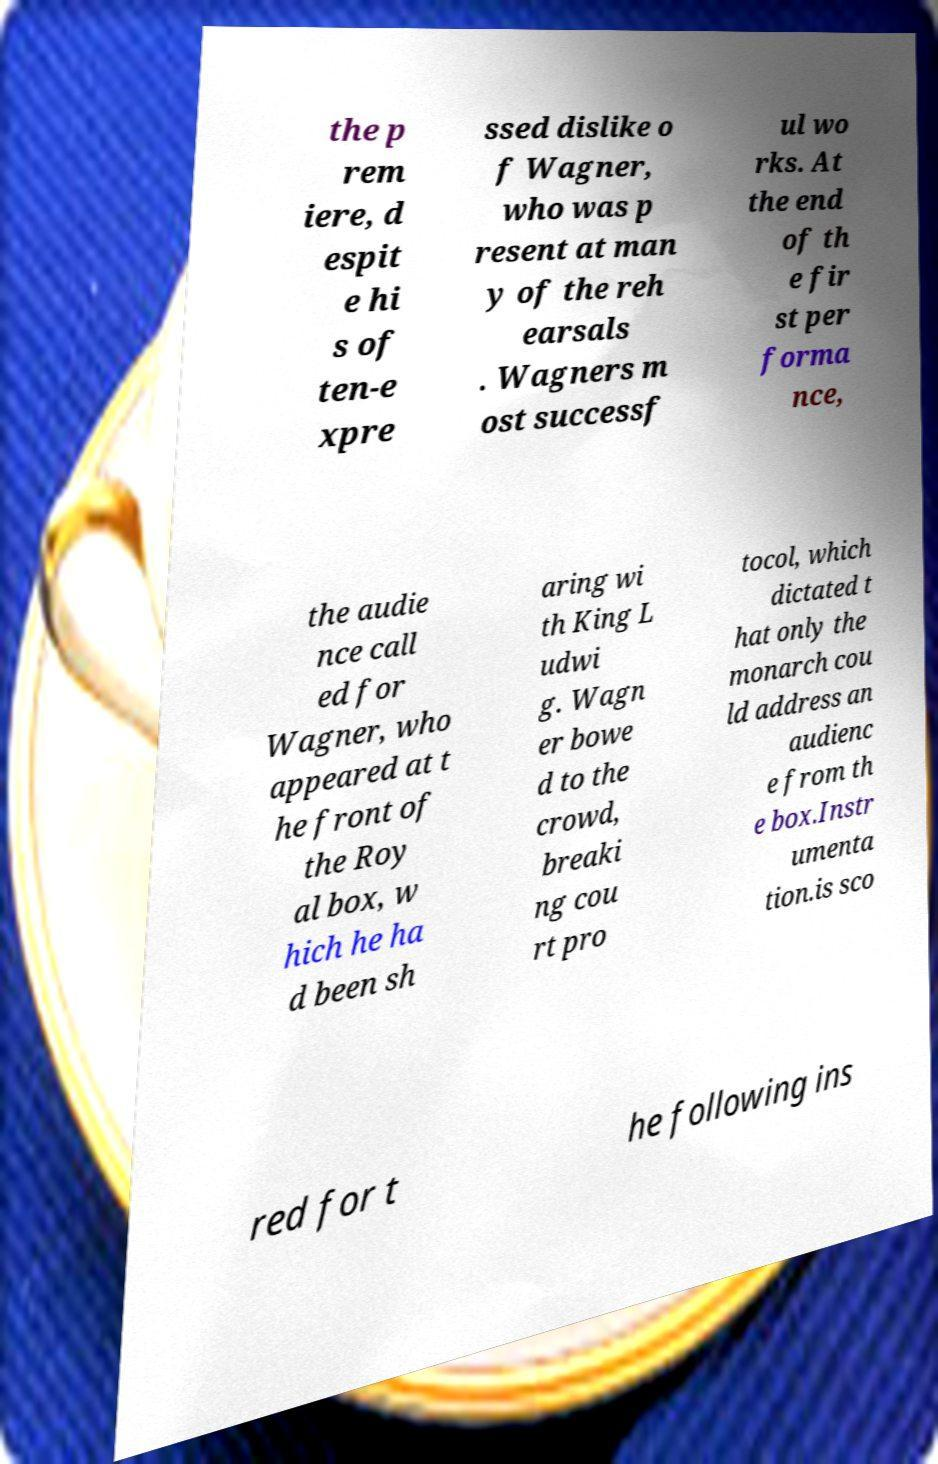What messages or text are displayed in this image? I need them in a readable, typed format. the p rem iere, d espit e hi s of ten-e xpre ssed dislike o f Wagner, who was p resent at man y of the reh earsals . Wagners m ost successf ul wo rks. At the end of th e fir st per forma nce, the audie nce call ed for Wagner, who appeared at t he front of the Roy al box, w hich he ha d been sh aring wi th King L udwi g. Wagn er bowe d to the crowd, breaki ng cou rt pro tocol, which dictated t hat only the monarch cou ld address an audienc e from th e box.Instr umenta tion.is sco red for t he following ins 